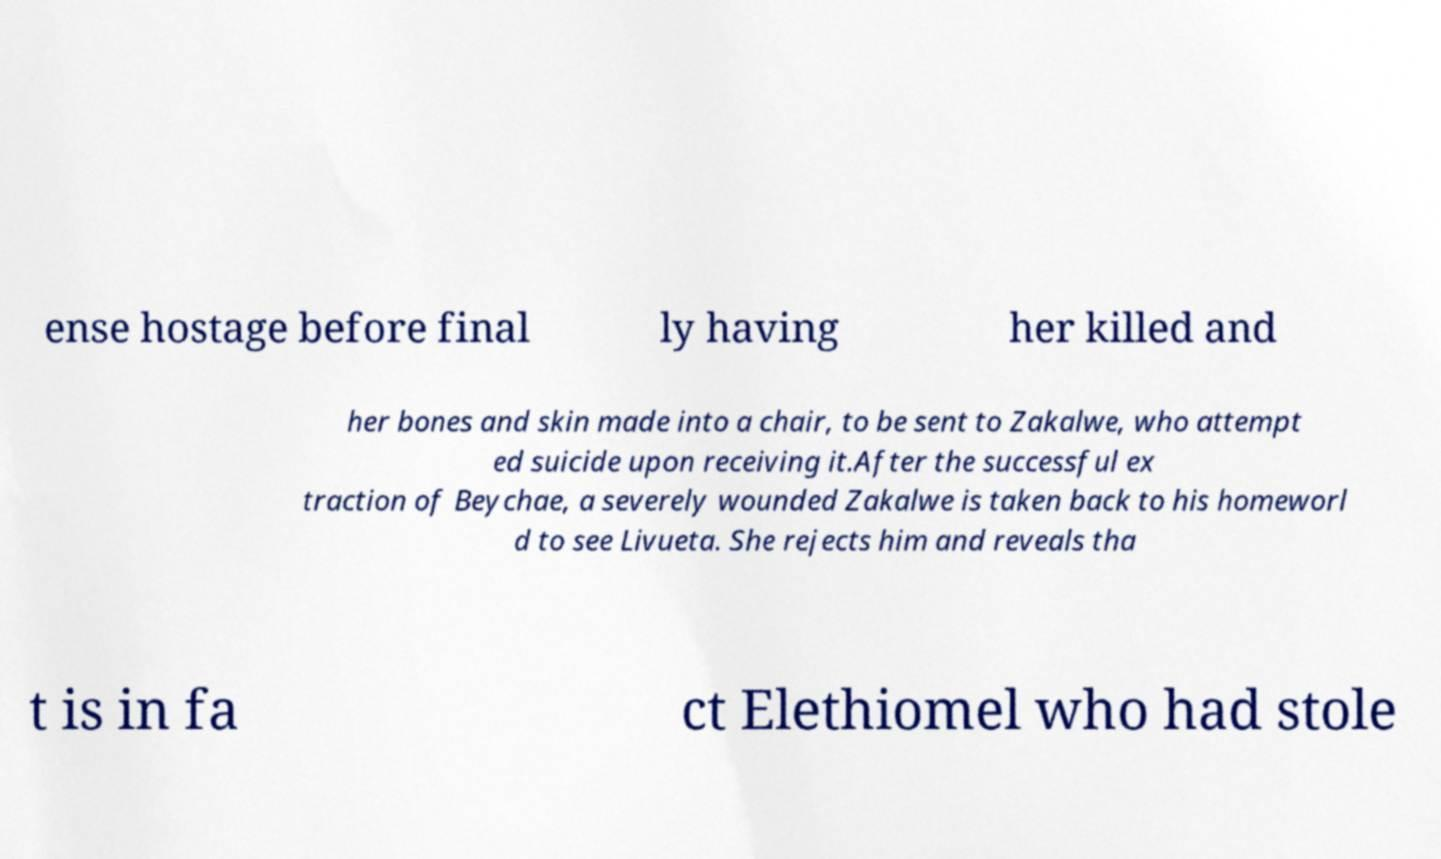There's text embedded in this image that I need extracted. Can you transcribe it verbatim? ense hostage before final ly having her killed and her bones and skin made into a chair, to be sent to Zakalwe, who attempt ed suicide upon receiving it.After the successful ex traction of Beychae, a severely wounded Zakalwe is taken back to his homeworl d to see Livueta. She rejects him and reveals tha t is in fa ct Elethiomel who had stole 